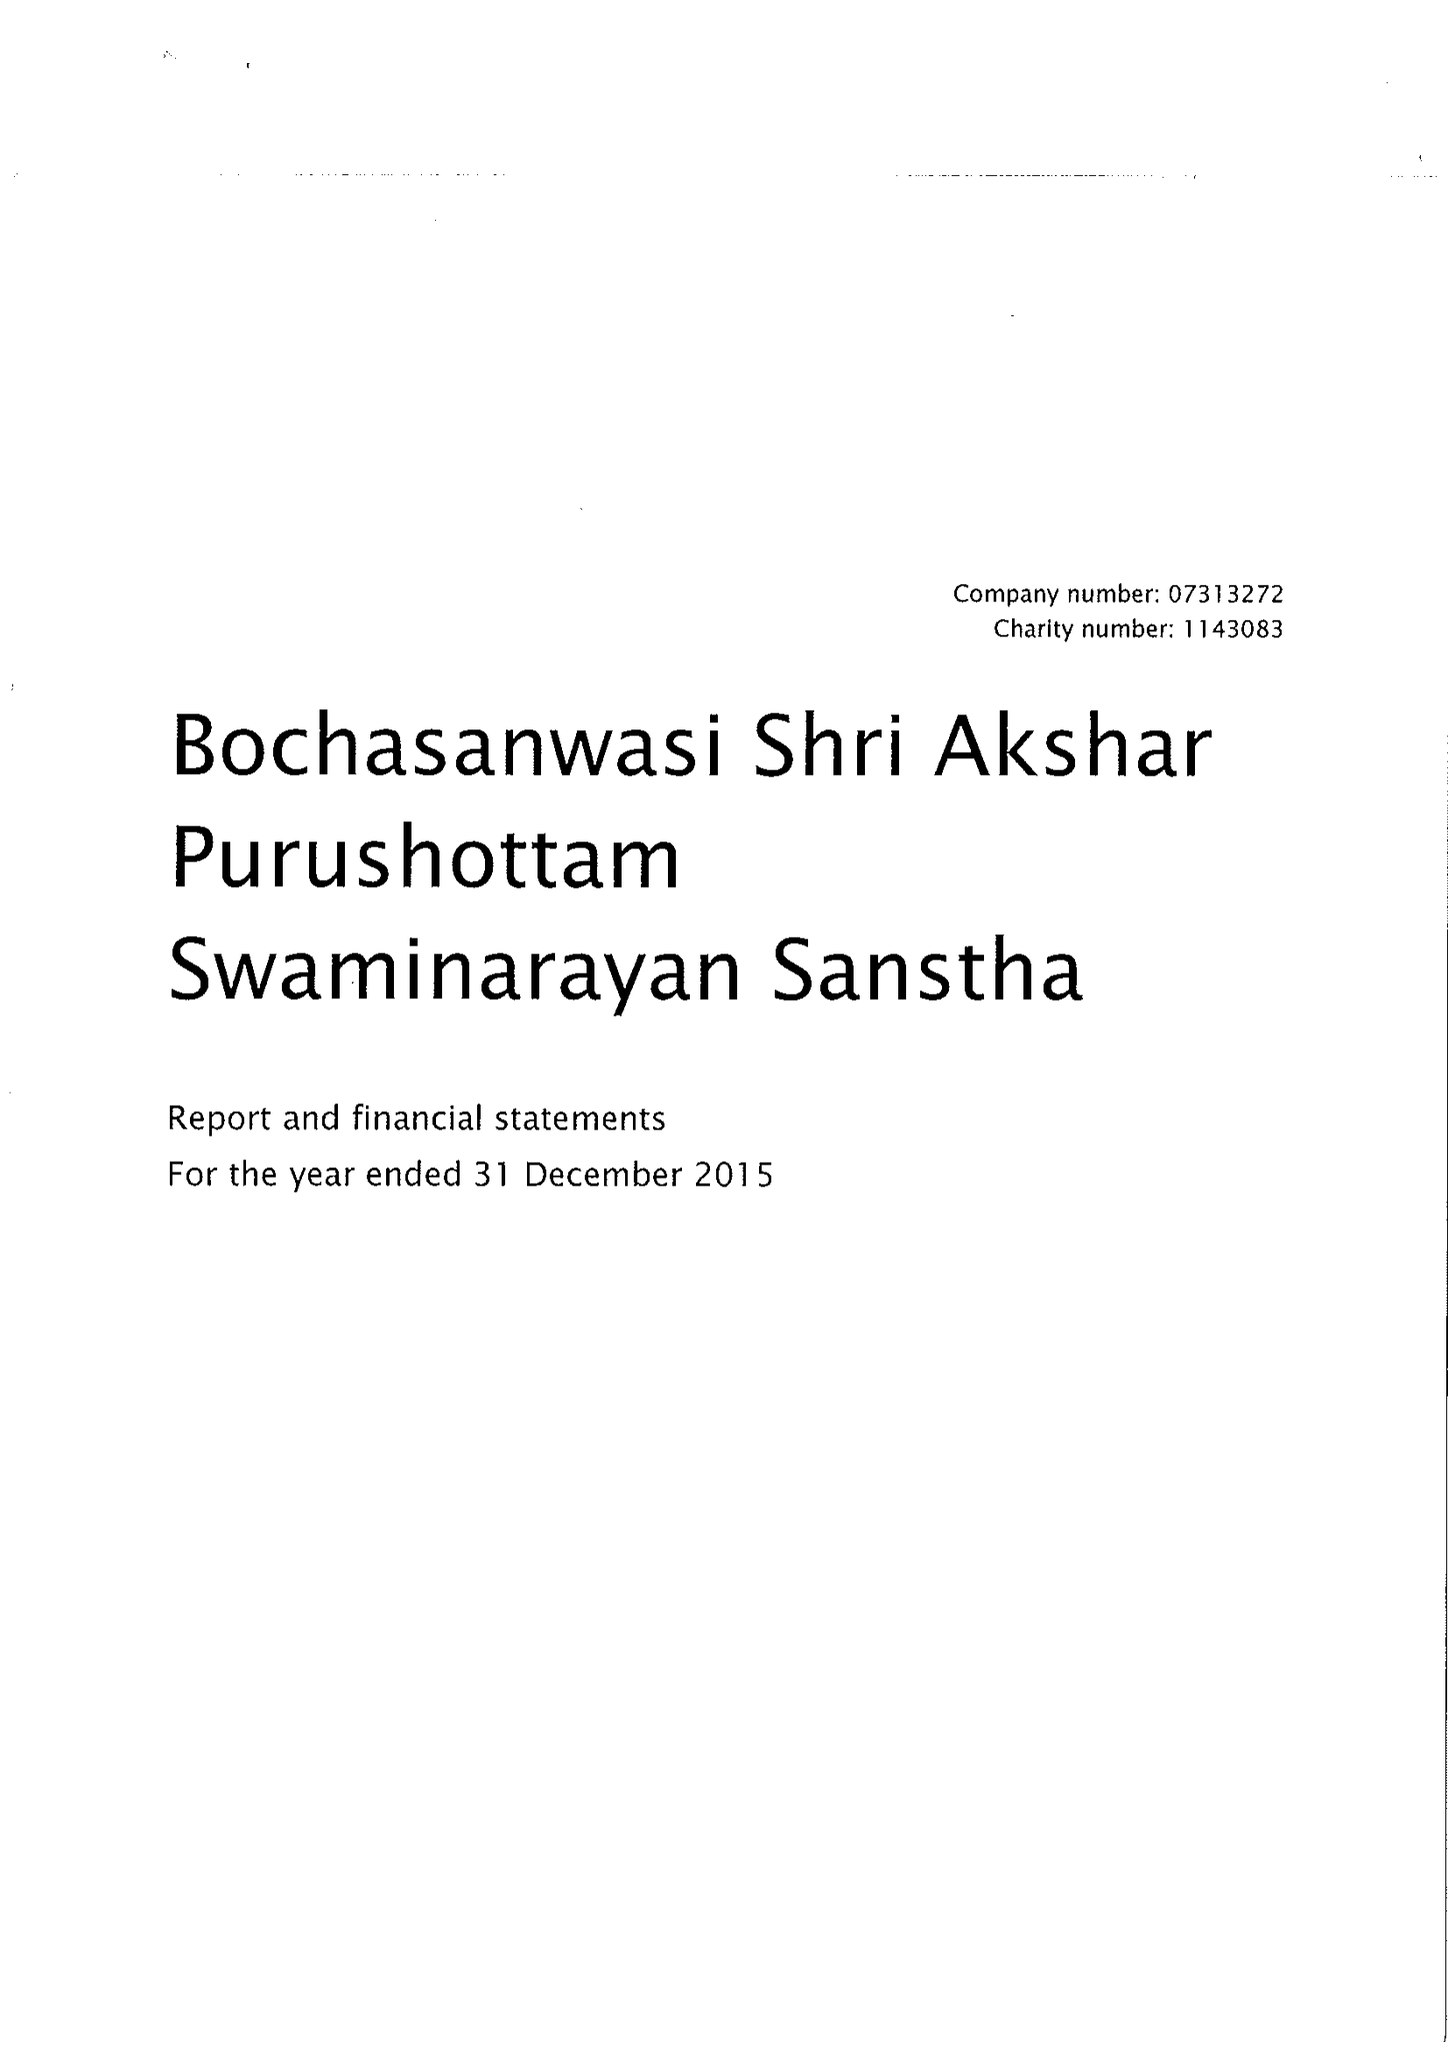What is the value for the income_annually_in_british_pounds?
Answer the question using a single word or phrase. 11311252.00 